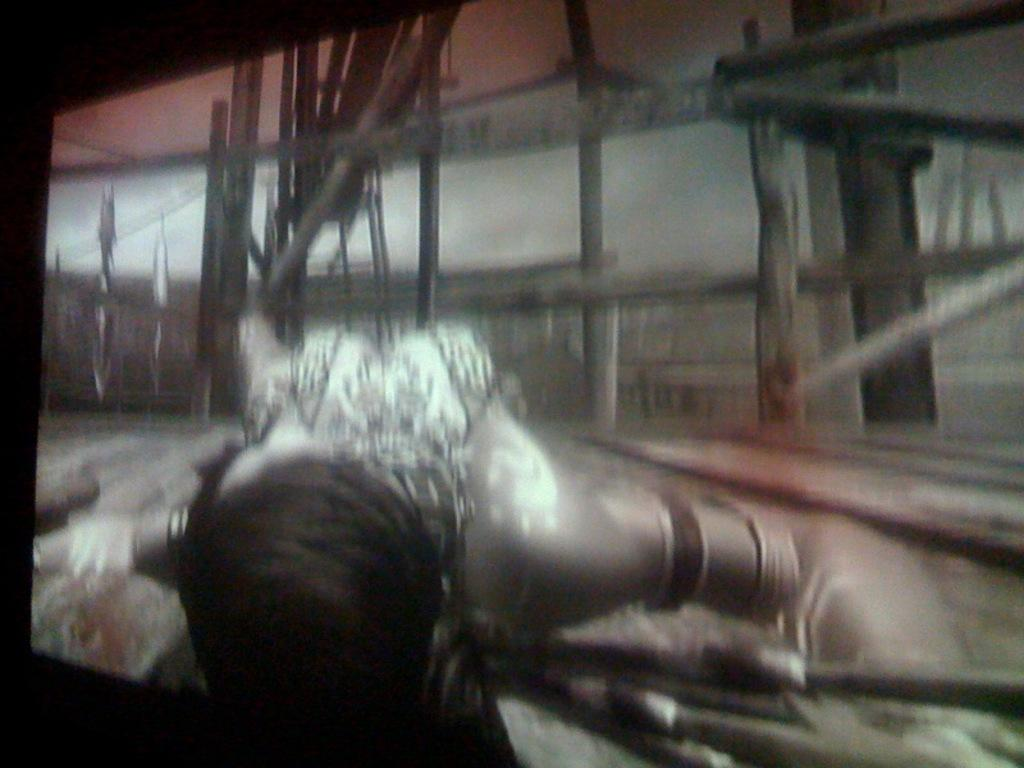What is the main object in the image? There is a screen in the image. Can you describe what is happening on the screen? A person is visible at the bottom of the screen. What can be seen in the background of the screen? There are wooden poles in the background of the screen. How many spots can be seen on the doll in the image? There is no doll present in the image, so it is not possible to determine the number of spots on a doll. 